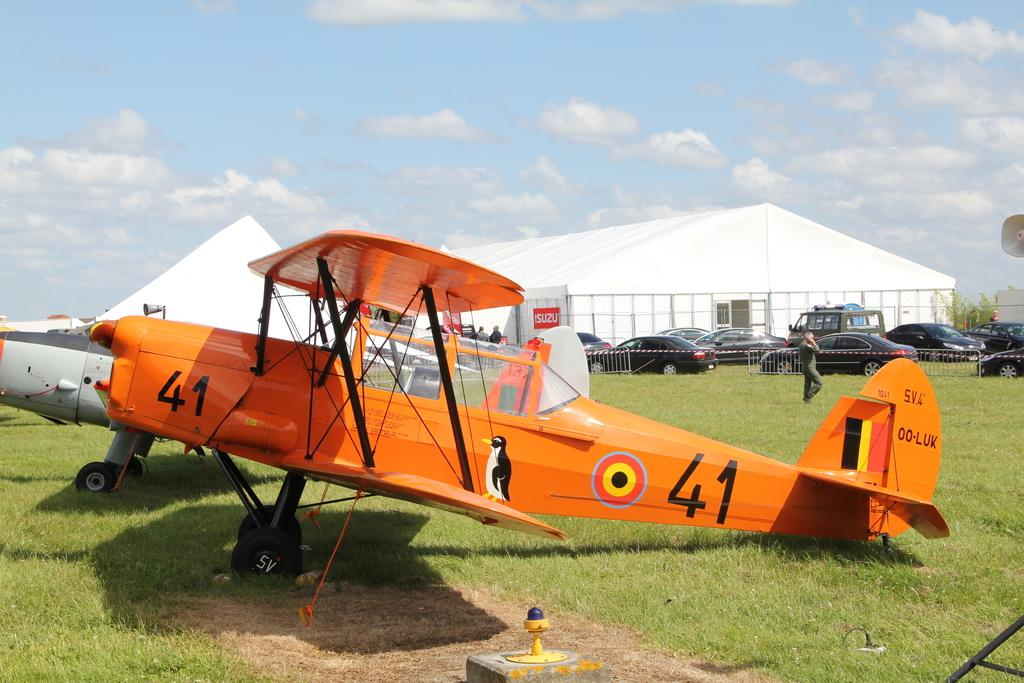<image>
Summarize the visual content of the image. An orange plane with the numbers 41 written on it 